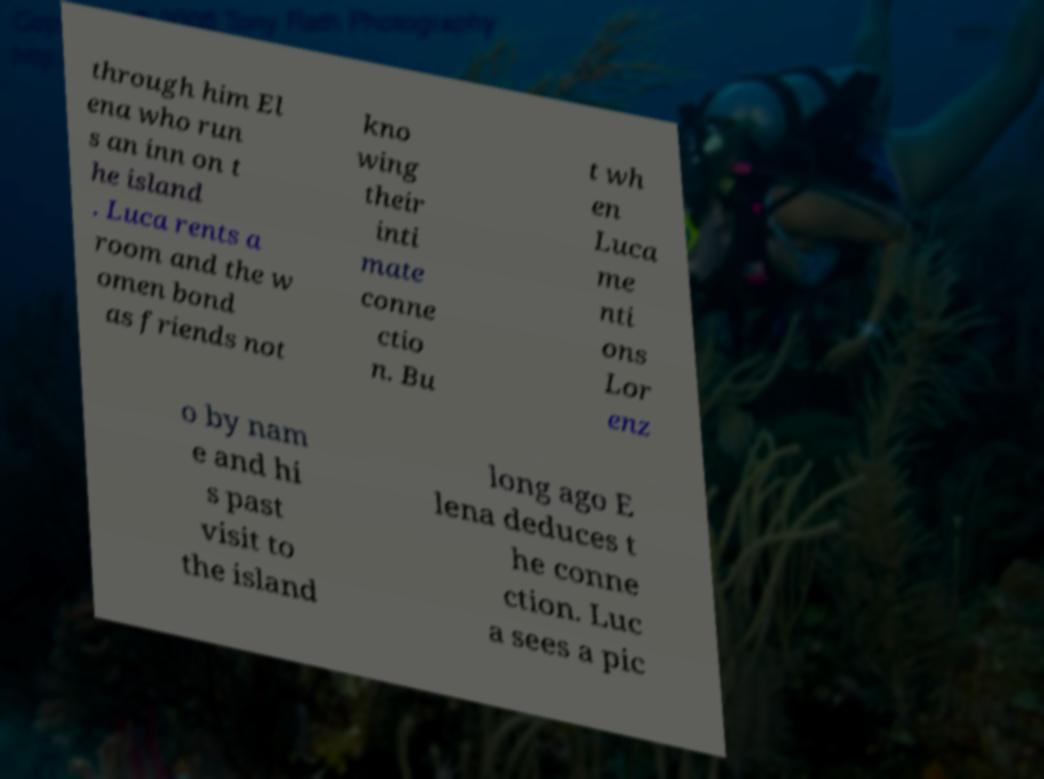Can you accurately transcribe the text from the provided image for me? through him El ena who run s an inn on t he island . Luca rents a room and the w omen bond as friends not kno wing their inti mate conne ctio n. Bu t wh en Luca me nti ons Lor enz o by nam e and hi s past visit to the island long ago E lena deduces t he conne ction. Luc a sees a pic 